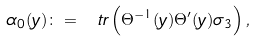<formula> <loc_0><loc_0><loc_500><loc_500>\alpha _ { 0 } ( y ) \colon = \ t r \left ( \Theta ^ { - 1 } ( y ) \Theta ^ { \prime } ( y ) \sigma _ { 3 } \right ) ,</formula> 